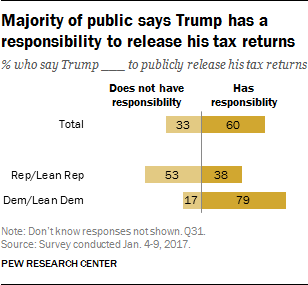List a handful of essential elements in this visual. The sum value of Rep/Lean Rep and Dem/Lean dem having responsibility is 117. The yellow bar has a lowest value of 38. 